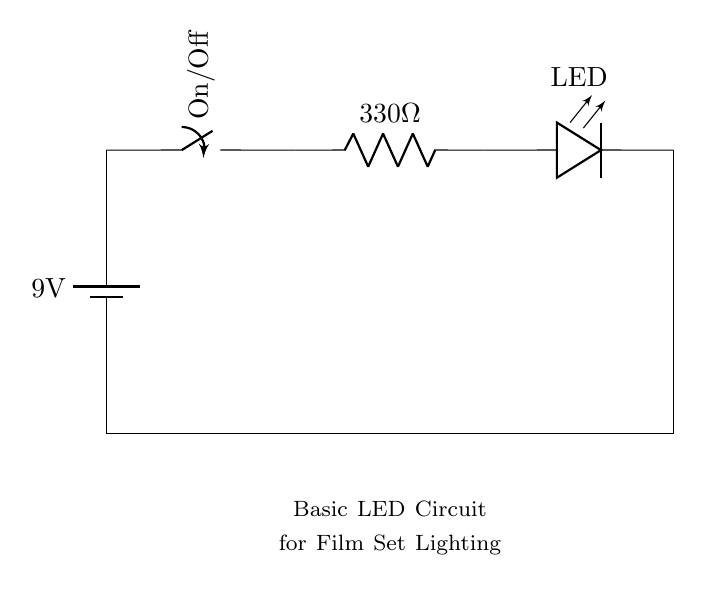What is the voltage of the power source? The circuit contains a battery labeled with a voltage of nine volts. This is the source of electrical power for the circuit.
Answer: nine volts What type of switch is used in this circuit? The circuit uses a single pole double throw (SPDT) switch, which can be turned on or off to control the flow of current.
Answer: SPDT What is the resistance value of the resistor? The resistor in the circuit is labeled with a value of three hundred thirty ohms, which limits the current flowing through the LED.
Answer: three hundred thirty ohms How is the LED connected in the circuit? The LED is connected in series after the resistor, meaning the current flows first through the resistor and then through the LED. This arrangement is essential for proper functioning, as the resistor protects the LED from too much current.
Answer: in series What function does the resistor serve in this circuit? The resistor limits the current flowing through the LED, preventing it from exceeding the maximum current rating and thus protecting it from damage. This is crucial for maintaining the LED's longevity and performance.
Answer: current limiting 